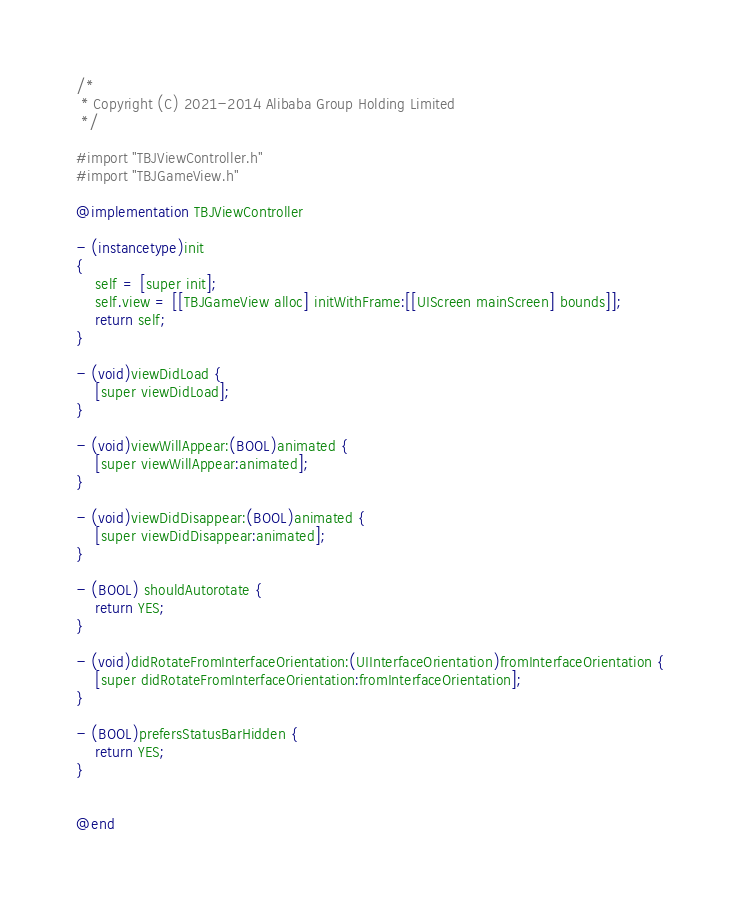Convert code to text. <code><loc_0><loc_0><loc_500><loc_500><_ObjectiveC_>/*
 * Copyright (C) 2021-2014 Alibaba Group Holding Limited
 */

#import "TBJViewController.h"
#import "TBJGameView.h"

@implementation TBJViewController

- (instancetype)init
{
    self = [super init];
    self.view = [[TBJGameView alloc] initWithFrame:[[UIScreen mainScreen] bounds]];
    return self;
}

- (void)viewDidLoad {
    [super viewDidLoad];
}

- (void)viewWillAppear:(BOOL)animated {
    [super viewWillAppear:animated];
}

- (void)viewDidDisappear:(BOOL)animated {
    [super viewDidDisappear:animated];
}

- (BOOL) shouldAutorotate {
    return YES;
}

- (void)didRotateFromInterfaceOrientation:(UIInterfaceOrientation)fromInterfaceOrientation {
    [super didRotateFromInterfaceOrientation:fromInterfaceOrientation];
}

- (BOOL)prefersStatusBarHidden {
    return YES;
}


@end
</code> 